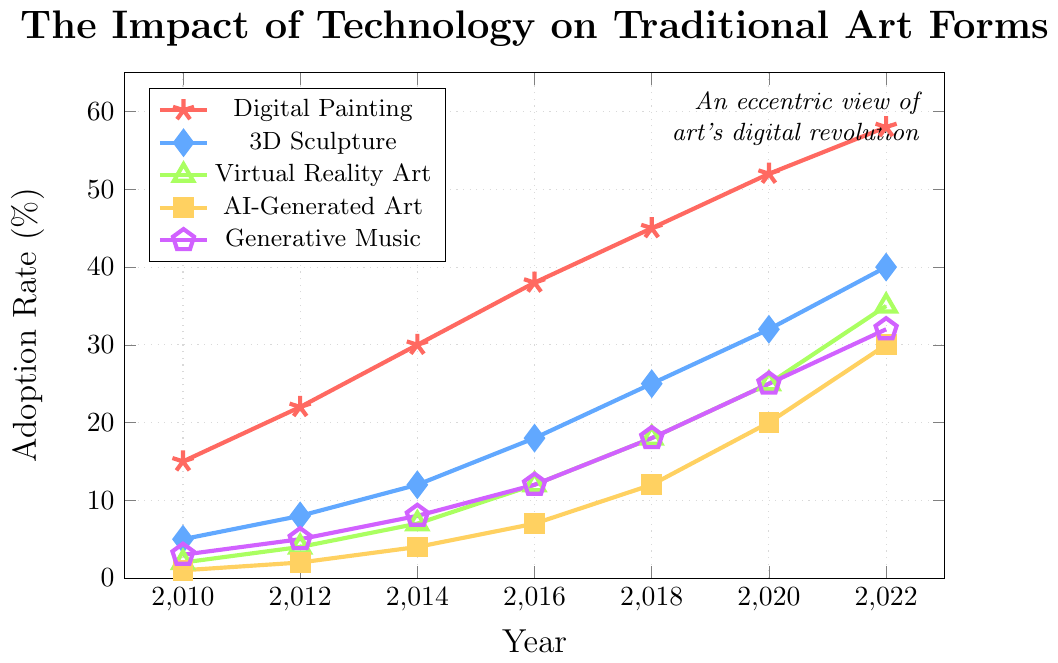What is the adoption rate of AI-Generated Art in 2020? In the provided figure, find the data point for AI-Generated Art in the year 2020. The adoption rate of AI-Generated Art can be seen as 20%.
Answer: 20% How has the adoption rate of Generative Music changed from 2010 to 2022? Look at the points representing Generative Music in 2010 and 2022. The adoption rate in 2010 was 3%, and in 2022, it increased to 32%. The change is calculated as 32% - 3% = 29%.
Answer: 29% Which artistic discipline showed the highest adoption rate in 2016? Find the adoption rates of all artistic disciplines in 2016. Digital Painting shows an adoption rate of 38%, 3D Sculpture 18%, Virtual Reality Art 12%, AI-Generated Art 7%, and Generative Music 12%. Digital Painting has the highest adoption rate.
Answer: Digital Painting Compare the adoption rate of Virtual Reality Art and AI-Generated Art in 2014. Which one was higher? Look at the adoption rates of Virtual Reality Art and AI-Generated Art in 2014. Virtual Reality Art had a 7% adoption rate, while AI-Generated Art had a 4% adoption rate. Virtual Reality Art was higher.
Answer: Virtual Reality Art What is the average adoption rate of Digital Painting from 2010 to 2022? Summarize the adoption rates of Digital Painting from 2010 to 2022: 15%, 22%, 30%, 38%, 45%, 52%, and 58%. Calculate the average: (15 + 22 + 30 + 38 + 45 + 52 + 58) / 7 = 37.14%.
Answer: 37.14% What was the least adopted digital tool in 2010? In 2010, compare the adoption rates of all digital tools. Digital Painting had 15%, 3D Sculpture 5%, Virtual Reality Art 2%, AI-Generated Art 1%, and Generative Music 3%. AI-Generated Art had the lowest adoption rate.
Answer: AI-Generated Art Did the adoption rate of 3D Sculpture ever surpass that of Digital Painting? Compare the adoption rates of 3D Sculpture and Digital Painting for all years provided. The highest adoption rate of 3D Sculpture was 40% in 2022, while Digital Painting had an adoption rate of 58% the same year. At no point did 3D Sculpture surpass Digital Painting.
Answer: No Calculate the total increase in adoption rate for Virtual Reality Art from 2010 to 2022. Determine the adoption rates of Virtual Reality Art in 2010 and 2022. The adoption rate in 2010 was 2%, and in 2022, it was 35%. The total increase is 35% - 2% = 33%.
Answer: 33% Which artistic discipline showed the most significant growth in adoption rate from 2010 to 2022? Compare the increase in adoption rates from 2010 to 2022 for all disciplines. Digital Painting increased from 15% to 58% (43% growth), 3D Sculpture from 5% to 40% (35% growth), Virtual Reality Art from 2% to 35% (33% growth), AI-Generated Art from 1% to 30% (29% growth), and Generative Music from 3% to 32% (29% growth). Digital Painting had the most significant growth.
Answer: Digital Painting Between 2016 and 2018, which digital tool had the largest increase in adoption rate? Compare the increase in adoption rates between 2016 and 2018 for all tools. Digital Painting increased by 7%, 3D Sculpture by 7%, Virtual Reality Art by 6%, AI-Generated Art by 5%, and Generative Music by 6%. Digital Painting and 3D Sculpture had the largest increase.
Answer: Digital Painting and 3D Sculpture 